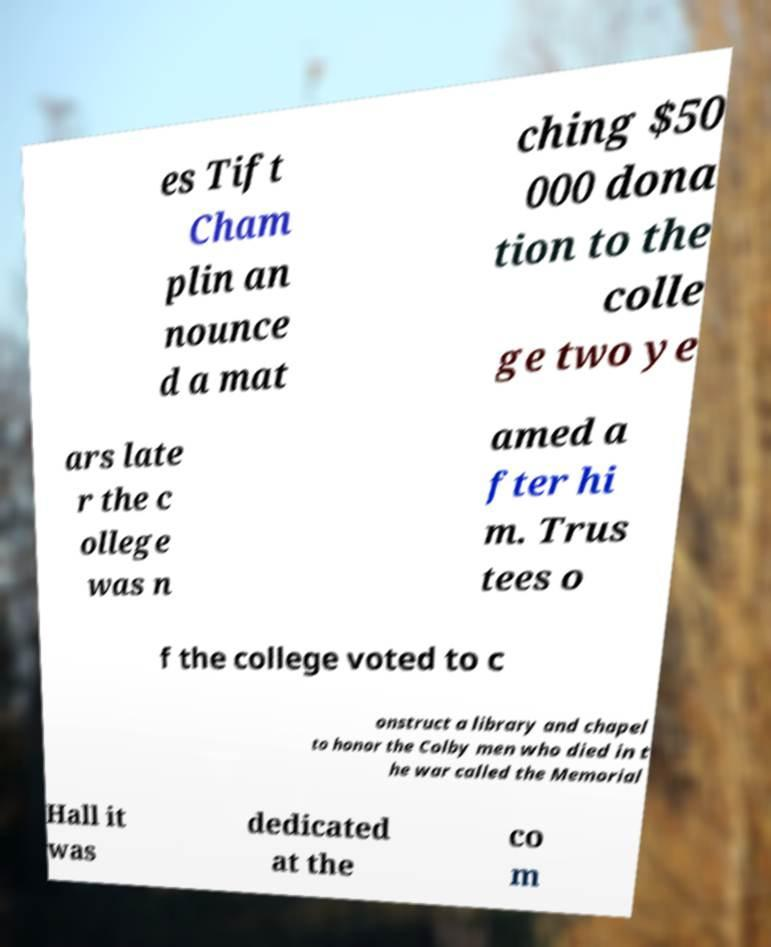Please read and relay the text visible in this image. What does it say? es Tift Cham plin an nounce d a mat ching $50 000 dona tion to the colle ge two ye ars late r the c ollege was n amed a fter hi m. Trus tees o f the college voted to c onstruct a library and chapel to honor the Colby men who died in t he war called the Memorial Hall it was dedicated at the co m 